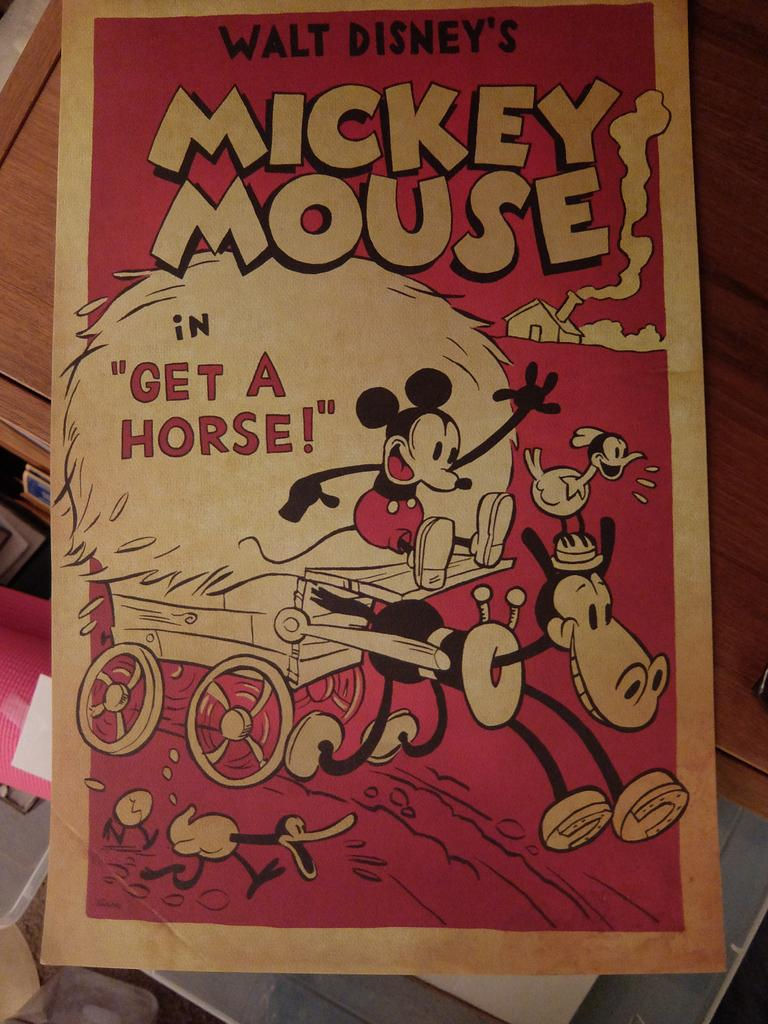<image>
Relay a brief, clear account of the picture shown. The faded and worn playbill is for Walt Disney's Micky Mouse in "Get A Horse!" 